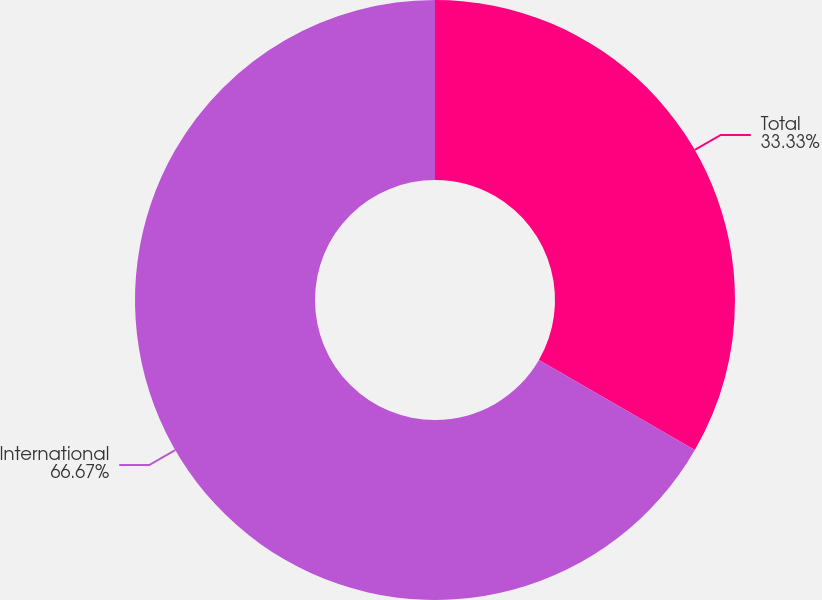<chart> <loc_0><loc_0><loc_500><loc_500><pie_chart><fcel>Total<fcel>International<nl><fcel>33.33%<fcel>66.67%<nl></chart> 